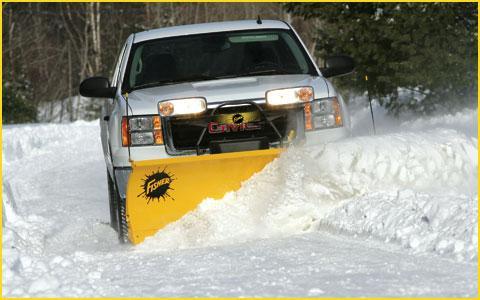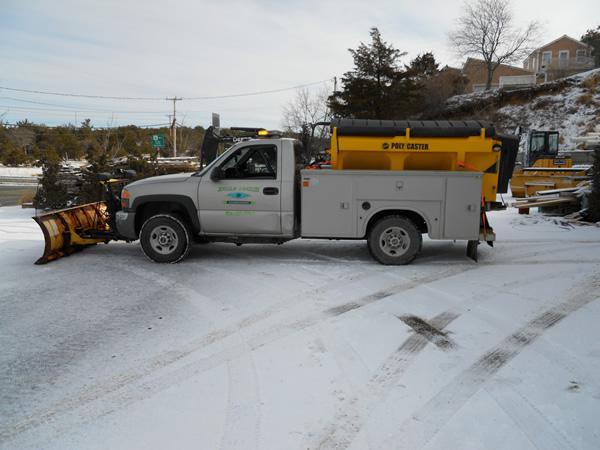The first image is the image on the left, the second image is the image on the right. For the images displayed, is the sentence "There are two or more trucks in the right image." factually correct? Answer yes or no. No. The first image is the image on the left, the second image is the image on the right. Examine the images to the left and right. Is the description "The left image shows a red truck with a red plow on its front, pushing snow and headed toward the camera." accurate? Answer yes or no. No. 